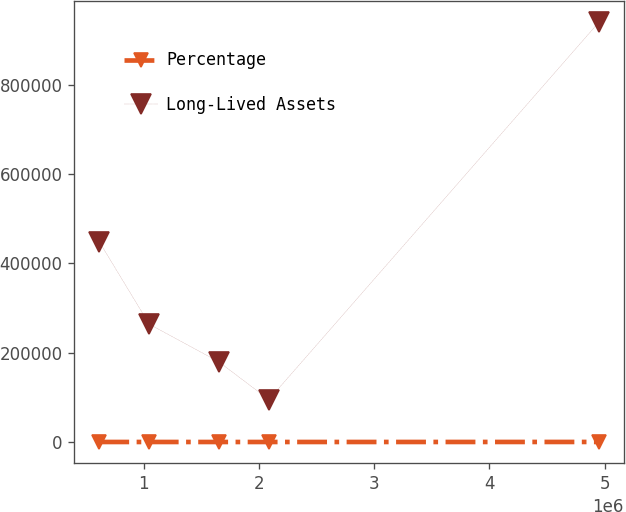Convert chart to OTSL. <chart><loc_0><loc_0><loc_500><loc_500><line_chart><ecel><fcel>Percentage<fcel>Long-Lived Assets<nl><fcel>615983<fcel>33.25<fcel>448507<nl><fcel>1.04937e+06<fcel>48.39<fcel>263952<nl><fcel>1.65384e+06<fcel>9.51<fcel>179464<nl><fcel>2.08722e+06<fcel>18.88<fcel>94975.4<nl><fcel>4.94981e+06<fcel>103.22<fcel>939860<nl></chart> 